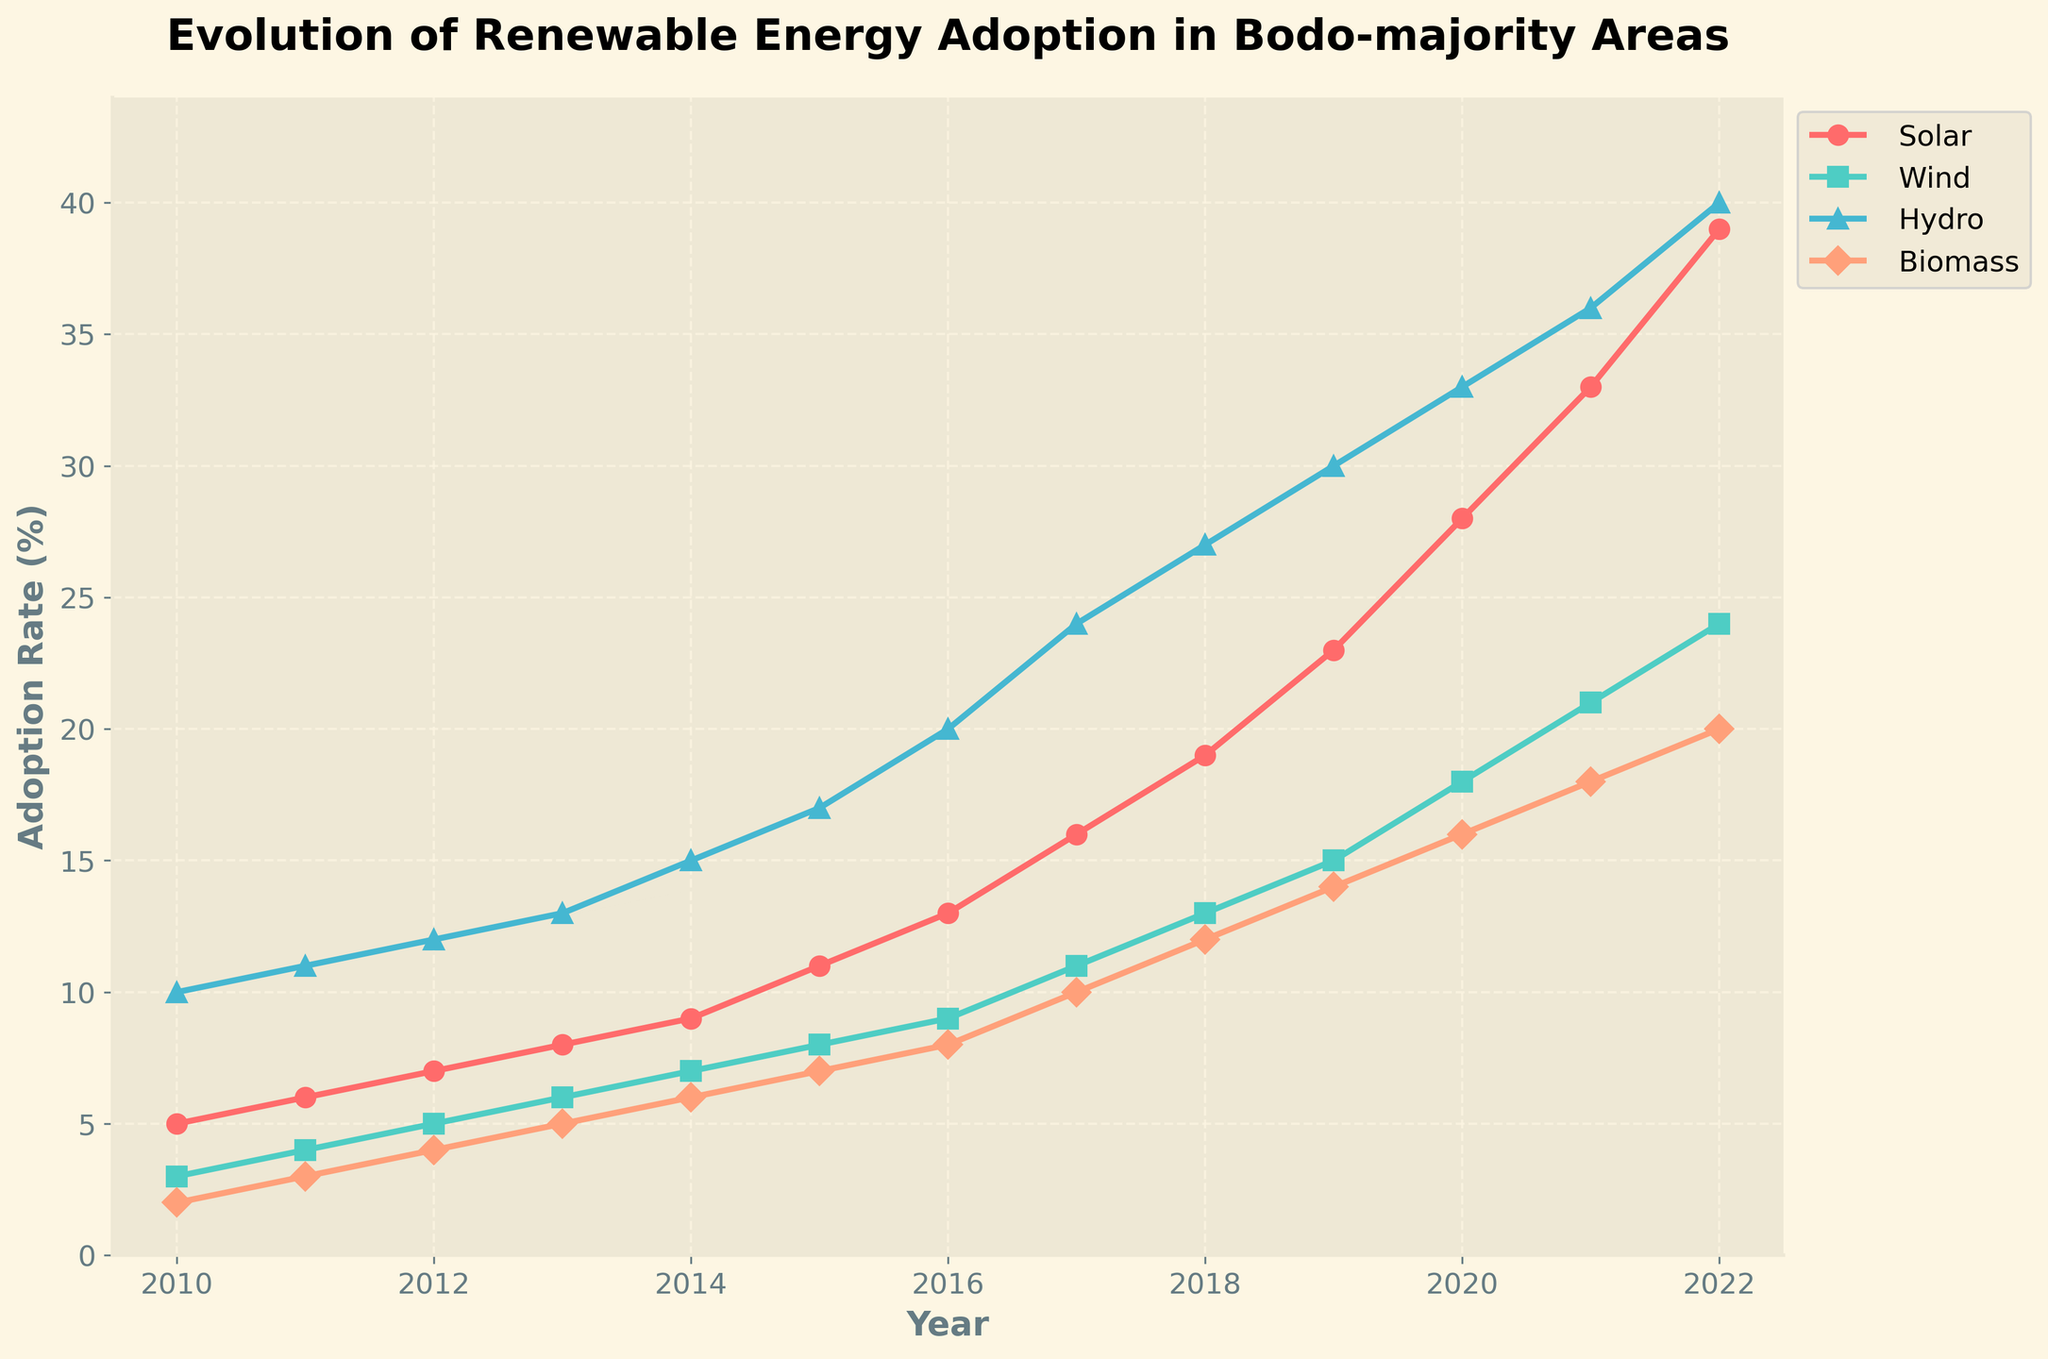What is the title of the plot? The title is displayed at the top of the plot. It reads, "Evolution of Renewable Energy Adoption in Bodo-majority Areas"
Answer: Evolution of Renewable Energy Adoption in Bodo-majority Areas How many types of renewable energy are depicted in the plot? There are four different lines in the plot, each representing a different type of renewable energy: Solar, Wind, Hydro, and Biomass
Answer: Four Which renewable energy type had the highest adoption rate by 2022? By looking at the endpoints of the lines, we can see that Solar has the highest adoption rate in 2022, reaching 39%
Answer: Solar In which year did Wind adoption first surpass 10%? By following the Wind line, we notice it surpasses 10% between 2016 and 2017, and precisely in 2017, it reaches 11%
Answer: 2017 Between 2015 and 2016, which renewable energy type had the greatest increase in adoption rate? By examining the slopes of the lines between 2015 and 2016, Solar increased from 11% to 13%, Wind from 8% to 9%, Hydro from 17% to 20%, and Biomass from 7% to 8%. The largest increase is Hydro, with a 3% hike
Answer: Hydro What is the average adoption rate of Solar energy from 2010 to 2022? To find the average adoption rate of Solar energy, sum all the values from 2010 to 2022 and then divide by the number of years. (5+6+7+8+9+11+13+16+19+23+28+33+39) / 13 = 17.85
Answer: 17.85% Which renewable energy type shows the steepest increase in adoption rate over the years? The steepness of a line indicates the rate of increase. The Solar line, which starts at 5% in 2010 and ends at 39% in 2022, shows the steepest increase
Answer: Solar How does the Biomass adoption rate in 2022 compare to its rate in 2010? In 2010, Biomass adoption rate was 2%, and in 2022 it is 20%. The difference is 20% - 2% = 18%
Answer: 18% Which years show the most significant visual jump in Hydro adoption rates and what was the increase? The most significant jump is observed between 2013 and 2014, where Hydro adoption rate jumped from 13% to 15%, an increase of 2%
Answer: 2013 to 2014, 2% By how much did the Wind adoption rate increase between 2018 and 2020? In 2018, Wind adoption rate was 13%, and in 2020 it was 18%. The increase is 18% - 13% = 5%
Answer: 5% 